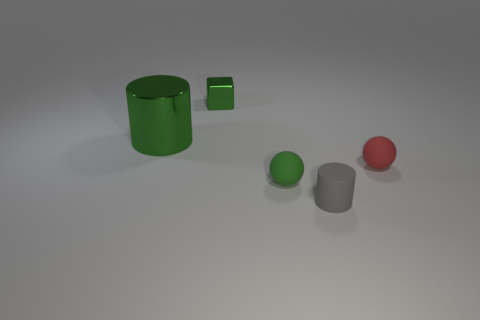Add 4 tiny metallic things. How many objects exist? 9 Subtract all green spheres. How many spheres are left? 1 Subtract all cylinders. How many objects are left? 3 Add 4 blue matte cubes. How many blue matte cubes exist? 4 Subtract 1 green cubes. How many objects are left? 4 Subtract all cyan balls. Subtract all brown cubes. How many balls are left? 2 Subtract all blue blocks. How many green spheres are left? 1 Subtract all cyan matte cylinders. Subtract all big green things. How many objects are left? 4 Add 4 metallic objects. How many metallic objects are left? 6 